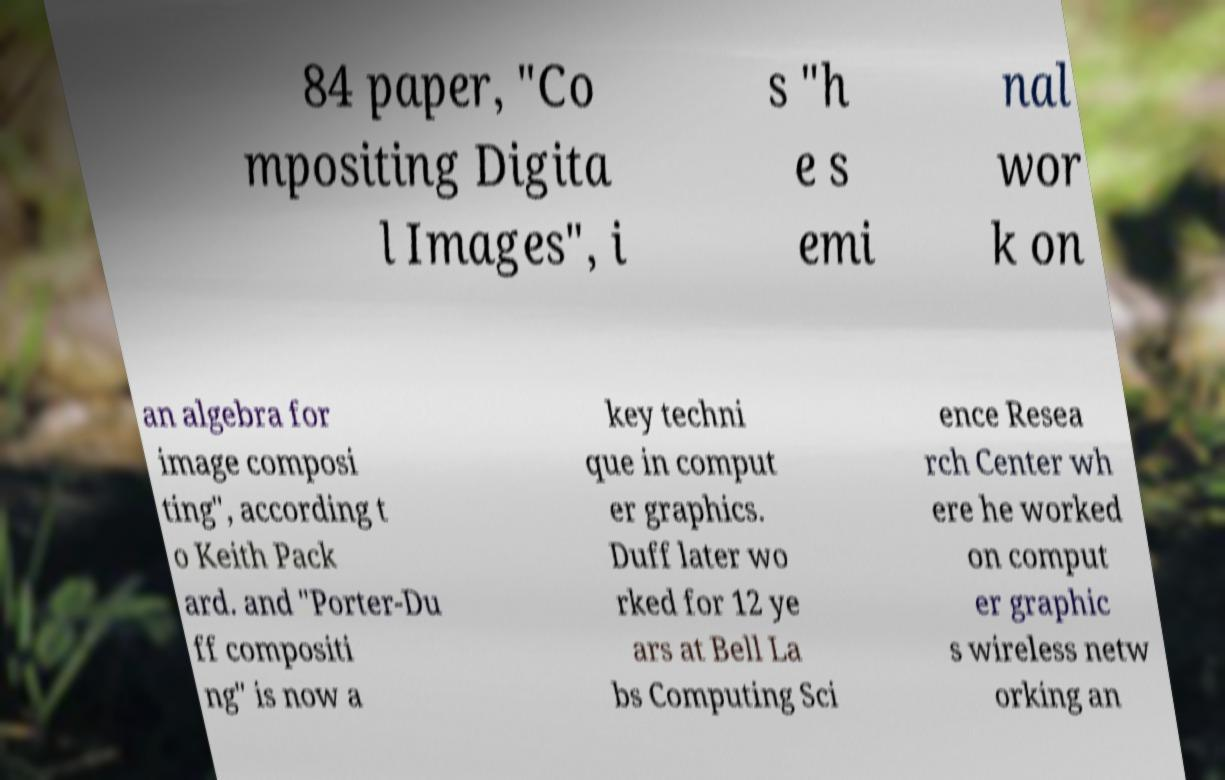I need the written content from this picture converted into text. Can you do that? 84 paper, "Co mpositing Digita l Images", i s "h e s emi nal wor k on an algebra for image composi ting", according t o Keith Pack ard. and "Porter-Du ff compositi ng" is now a key techni que in comput er graphics. Duff later wo rked for 12 ye ars at Bell La bs Computing Sci ence Resea rch Center wh ere he worked on comput er graphic s wireless netw orking an 